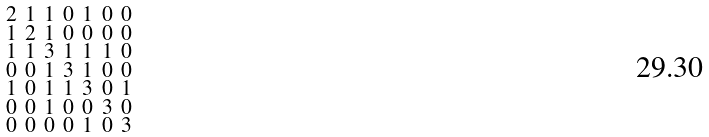<formula> <loc_0><loc_0><loc_500><loc_500>\begin{smallmatrix} 2 & 1 & 1 & 0 & 1 & 0 & 0 \\ 1 & 2 & 1 & 0 & 0 & 0 & 0 \\ 1 & 1 & 3 & 1 & 1 & 1 & 0 \\ 0 & 0 & 1 & 3 & 1 & 0 & 0 \\ 1 & 0 & 1 & 1 & 3 & 0 & 1 \\ 0 & 0 & 1 & 0 & 0 & 3 & 0 \\ 0 & 0 & 0 & 0 & 1 & 0 & 3 \end{smallmatrix}</formula> 